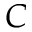Convert formula to latex. <formula><loc_0><loc_0><loc_500><loc_500>C</formula> 